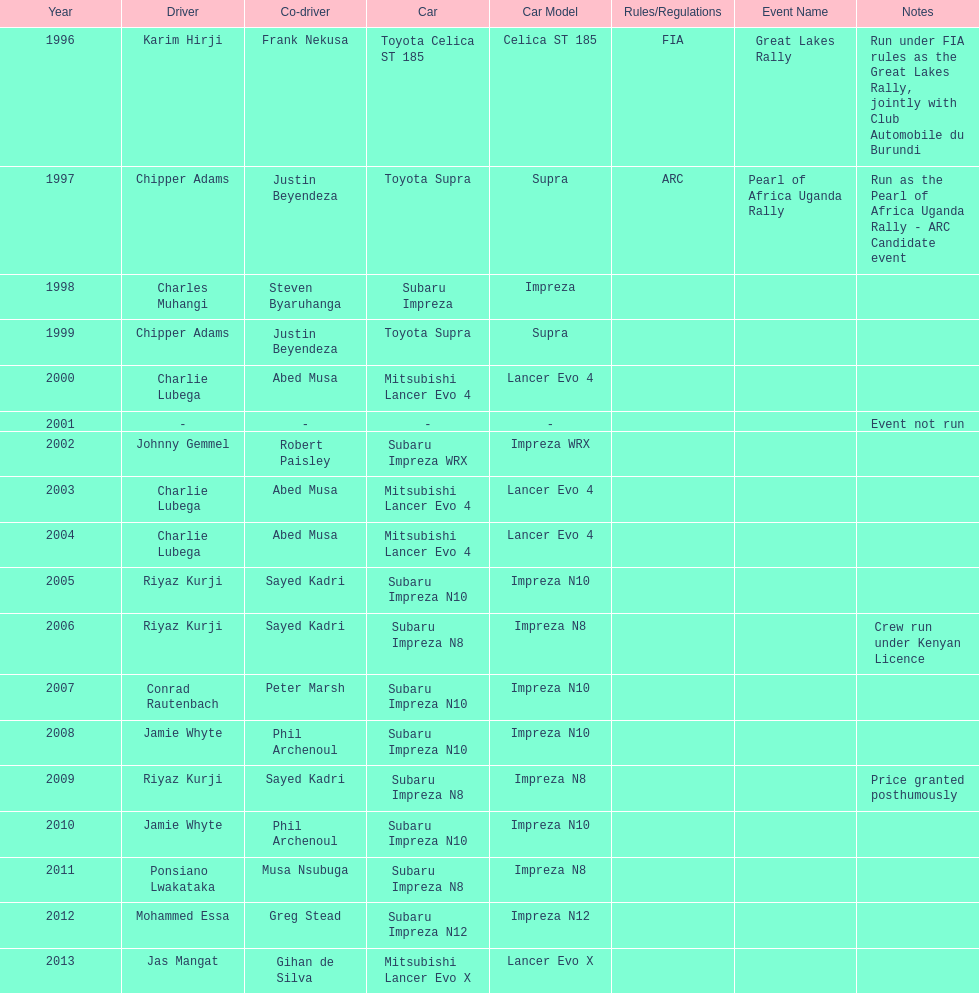How many times was a mitsubishi lancer the winning car before the year 2004? 2. 